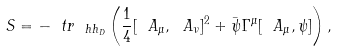<formula> <loc_0><loc_0><loc_500><loc_500>S = - \ t r _ { \ h h _ { D } } \left ( \frac { 1 } { 4 } [ \ A _ { \mu } , \ A _ { \nu } ] ^ { 2 } + \bar { \psi } \Gamma ^ { \mu } [ \ A _ { \mu } , \psi ] \right ) ,</formula> 